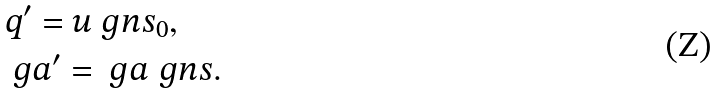<formula> <loc_0><loc_0><loc_500><loc_500>& q ^ { \prime } = u ^ { \ } g n s _ { 0 } , \\ & \ g a ^ { \prime } = \ g a ^ { \ } g n s .</formula> 